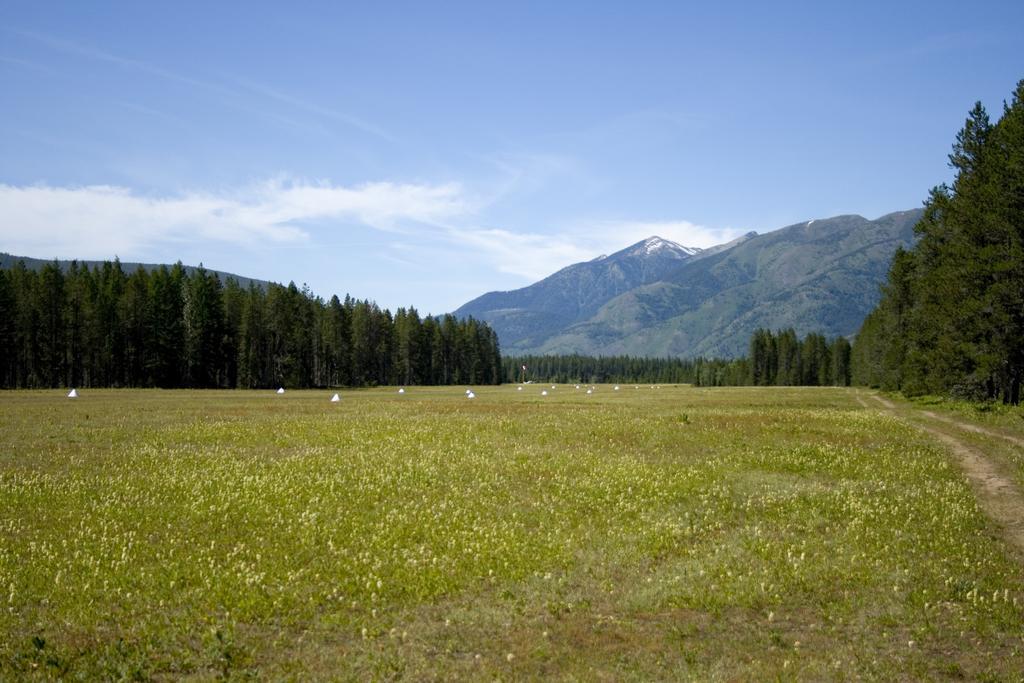In one or two sentences, can you explain what this image depicts? In this picture we can see plants, white objects and trees. In the background of the image we can see mountain and sky with clouds. 